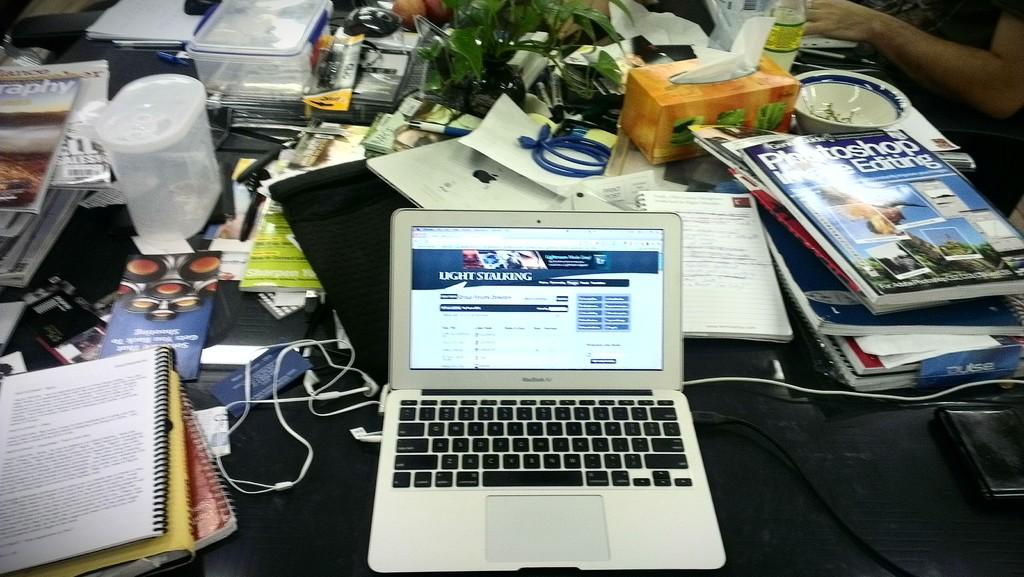<image>
Summarize the visual content of the image. A small Macbook Air computer shows a screen for Light Stalking 